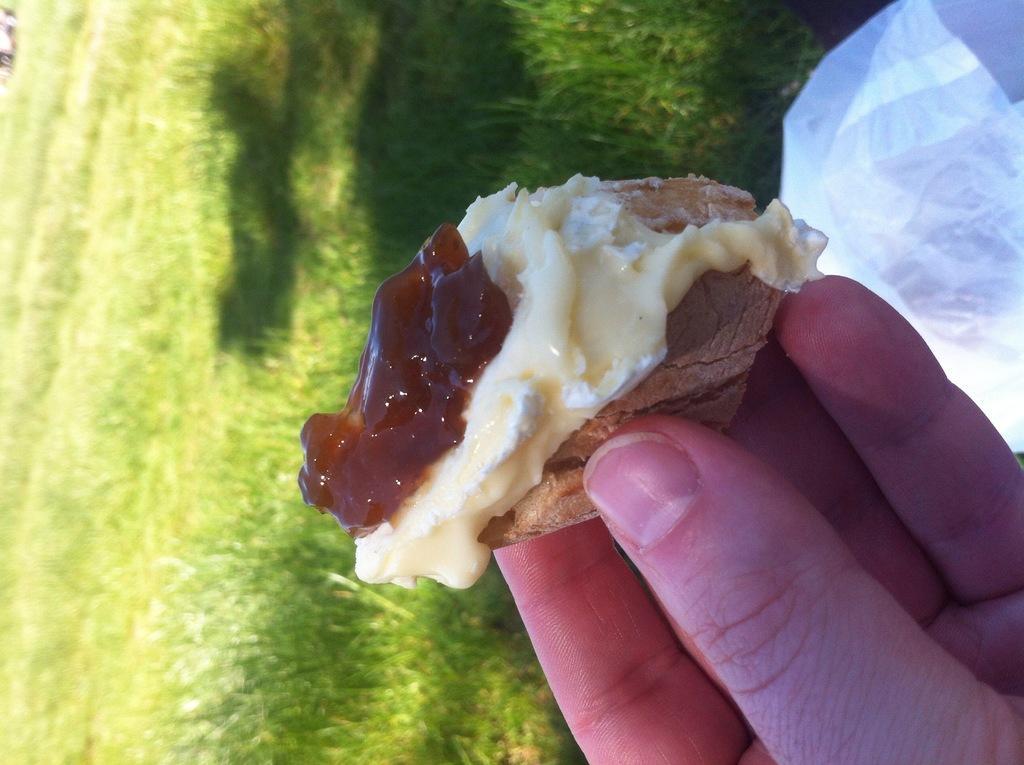Can you describe this image briefly? In this image there is a person's hand holding a food item. At the background of the image there is grass. 